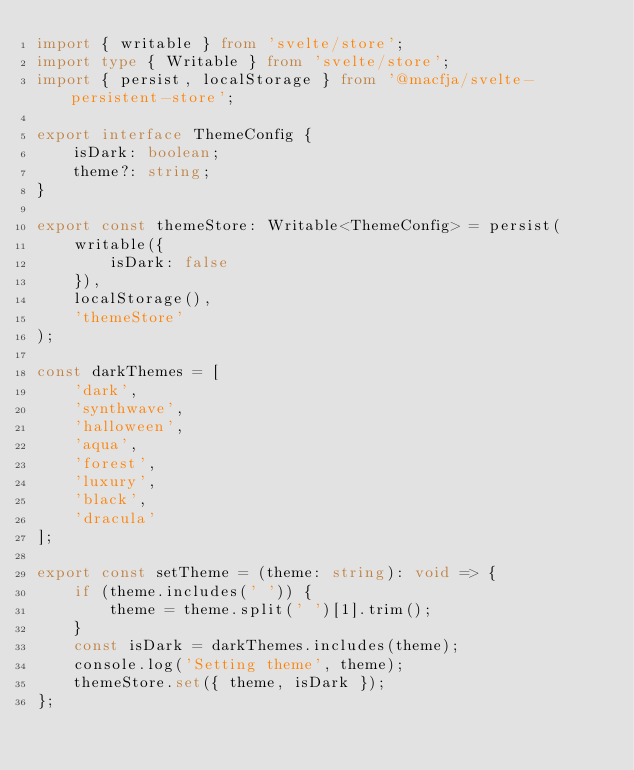<code> <loc_0><loc_0><loc_500><loc_500><_TypeScript_>import { writable } from 'svelte/store';
import type { Writable } from 'svelte/store';
import { persist, localStorage } from '@macfja/svelte-persistent-store';

export interface ThemeConfig {
	isDark: boolean;
	theme?: string;
}

export const themeStore: Writable<ThemeConfig> = persist(
	writable({
		isDark: false
	}),
	localStorage(),
	'themeStore'
);

const darkThemes = [
	'dark',
	'synthwave',
	'halloween',
	'aqua',
	'forest',
	'luxury',
	'black',
	'dracula'
];

export const setTheme = (theme: string): void => {
	if (theme.includes(' ')) {
		theme = theme.split(' ')[1].trim();
	}
	const isDark = darkThemes.includes(theme);
	console.log('Setting theme', theme);
	themeStore.set({ theme, isDark });
};
</code> 